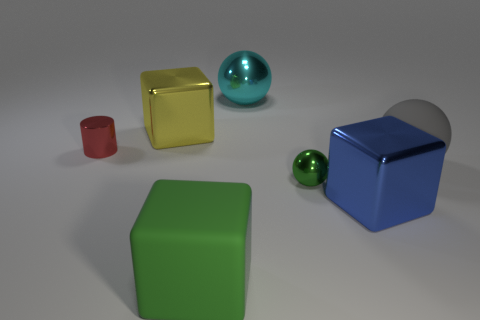Which objects in the image have reflective surfaces? The sphere and the small cube both have reflective surfaces, which contrast with the matte finish of the other objects. 